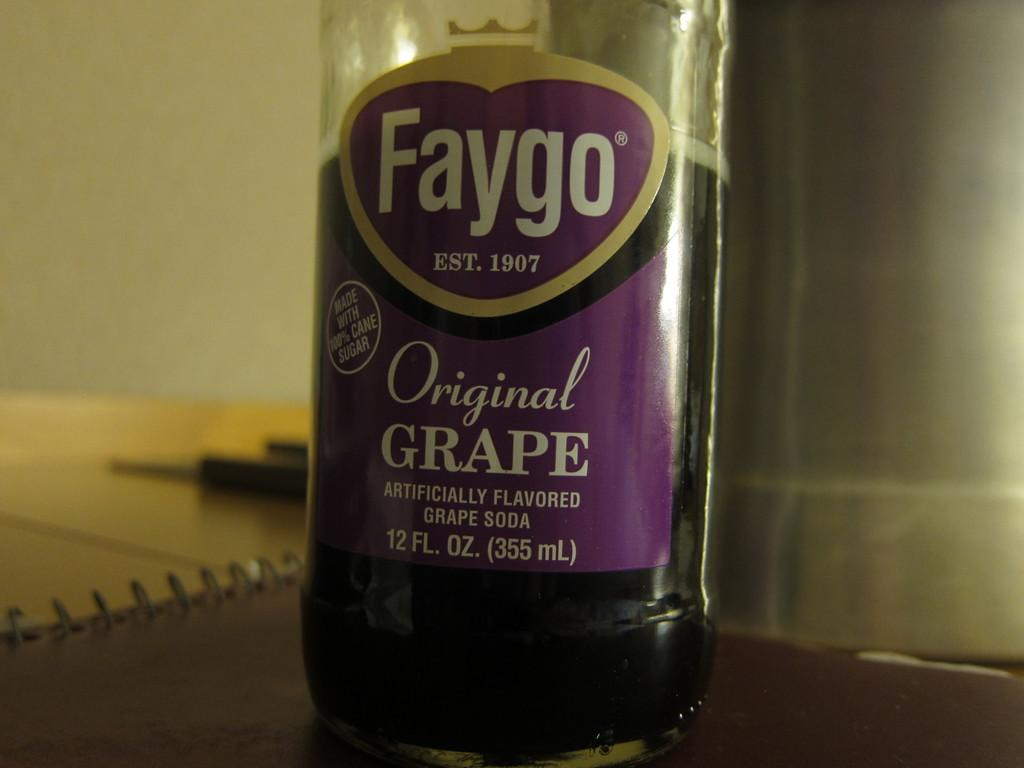<image>
Summarize the visual content of the image. Faygo, established in 1907, manufacturer's bottles of original grape soda. 